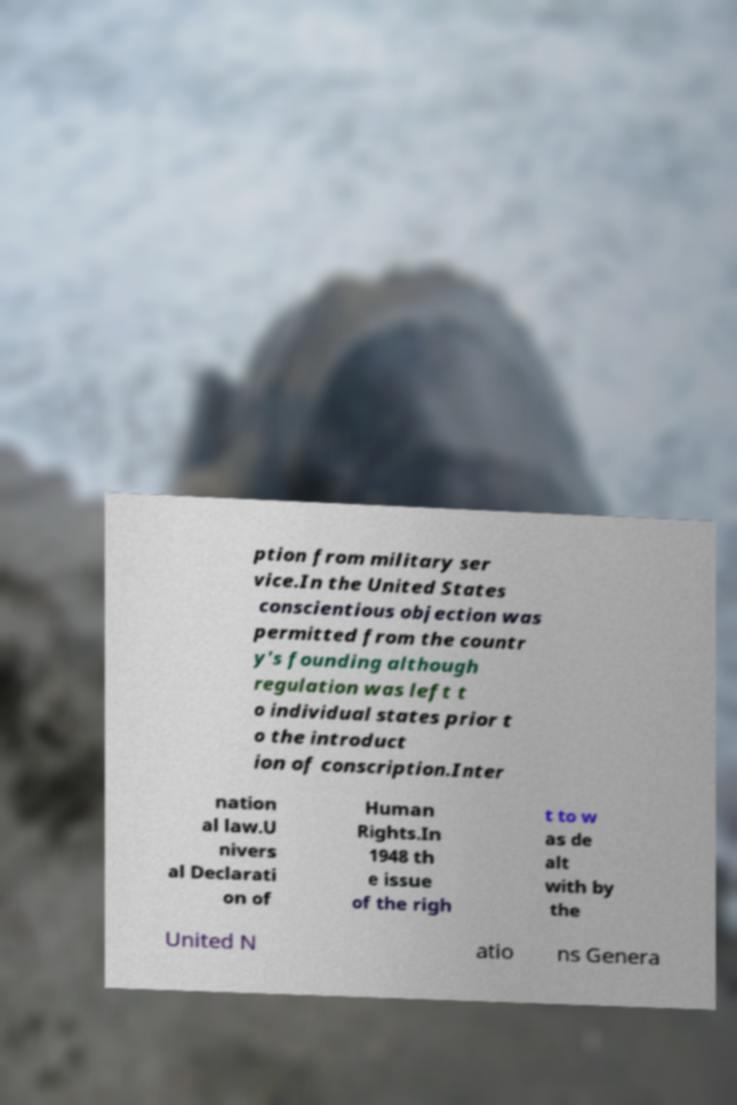Please read and relay the text visible in this image. What does it say? ption from military ser vice.In the United States conscientious objection was permitted from the countr y's founding although regulation was left t o individual states prior t o the introduct ion of conscription.Inter nation al law.U nivers al Declarati on of Human Rights.In 1948 th e issue of the righ t to w as de alt with by the United N atio ns Genera 